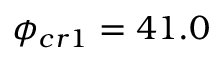Convert formula to latex. <formula><loc_0><loc_0><loc_500><loc_500>\phi _ { c r 1 } = 4 1 . 0</formula> 